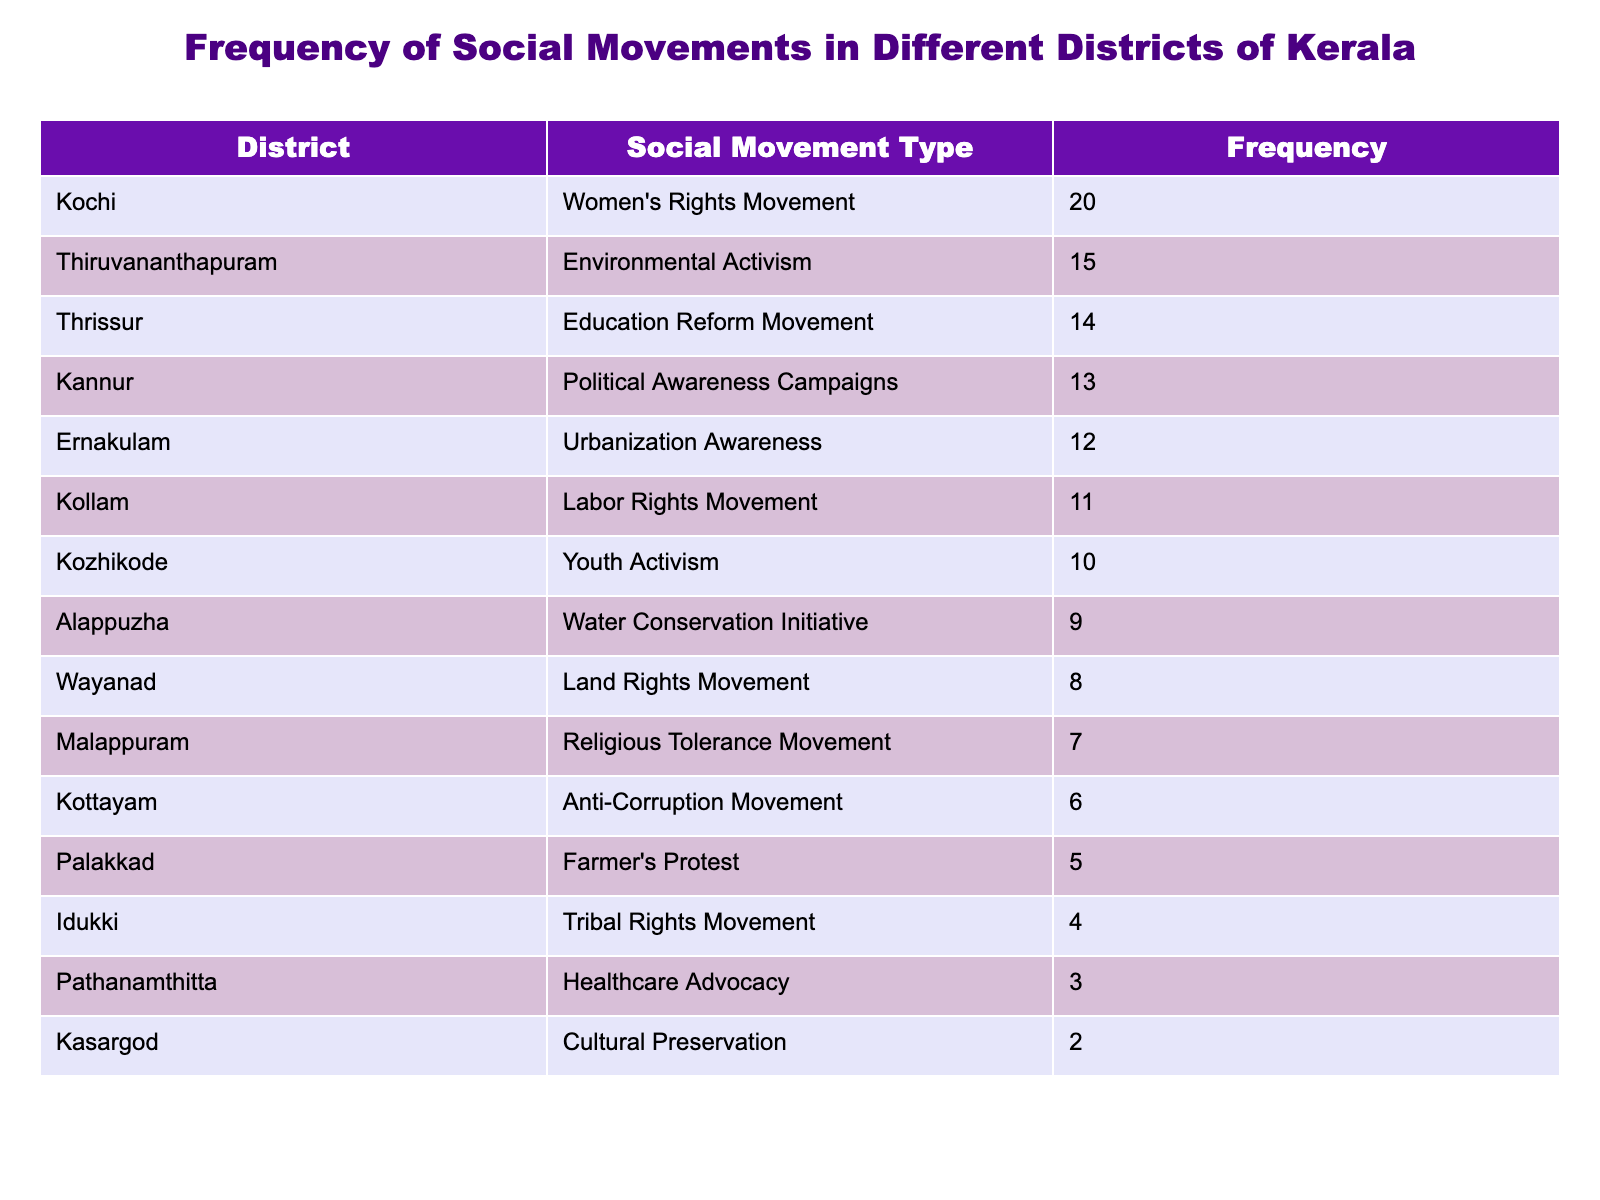What is the frequency of environmental activism in Thiruvananthapuram? The table shows that Thiruvananthapuram has a frequency of 15 for environmental activism.
Answer: 15 Which district has the highest frequency of social movements? After reviewing the table, Kochi has the highest frequency with a value of 20 for women's rights movement.
Answer: Kochi What is the total frequency of labor rights and farmer's protest movements combined? The frequency of labor rights movement in Kollam is 11 and for farmer's protest in Palakkad, it is 5. Adding them together gives 11 + 5 = 16.
Answer: 16 Is there a district where the frequency of social movements is less than 5? The table shows that Kasargod has a frequency of 2 for cultural preservation, which is less than 5.
Answer: Yes What is the average frequency of social movements across all districts mentioned in the table? To find the average, we first sum all the frequencies: 15 + 20 + 10 + 5 + 7 + 6 + 4 + 8 + 12 + 9 + 11 + 14 + 3 + 2 + 13 =  15 + 20 + 10 + 5 + 7 + 6 + 4 + 8 + 12 + 9 + 11 + 14 + 3 + 2 + 13 =  10 + 14 + 11 + 21 =  19 + 10 = 10 = 78. There are 15 districts, so the average is 78 / 15 = 5.2.
Answer: 5.2 Which two types of social movements have a frequency greater than 10? From the table, the types of social movements with frequencies greater than 10 are women's rights movement (20) and political awareness campaigns (13).
Answer: 20 and 13 How many districts have frequencies of social movements less than 10? By examining the table, the districts with frequencies less than 10 are Palakkad (5), Malappuram (7), Kottayam (6), Idukki (4), Wayanad (8), Alappuzha (9), Pathanamthitta (3), and Kasargod (2), totaling 8 districts.
Answer: 8 